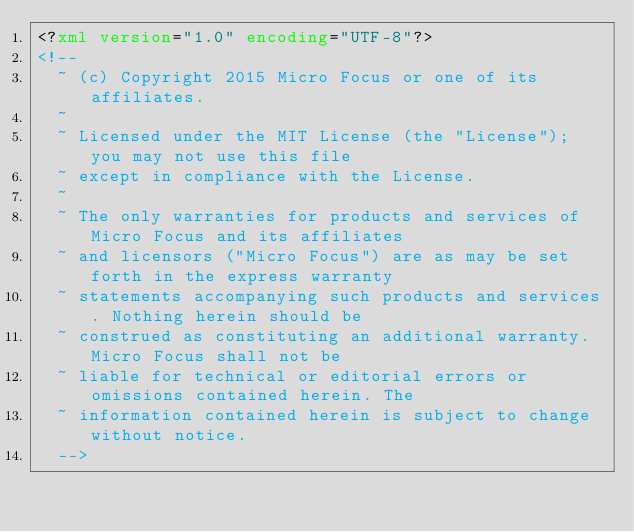<code> <loc_0><loc_0><loc_500><loc_500><_XML_><?xml version="1.0" encoding="UTF-8"?>
<!--
  ~ (c) Copyright 2015 Micro Focus or one of its affiliates.
  ~
  ~ Licensed under the MIT License (the "License"); you may not use this file
  ~ except in compliance with the License.
  ~
  ~ The only warranties for products and services of Micro Focus and its affiliates
  ~ and licensors ("Micro Focus") are as may be set forth in the express warranty
  ~ statements accompanying such products and services. Nothing herein should be
  ~ construed as constituting an additional warranty. Micro Focus shall not be
  ~ liable for technical or editorial errors or omissions contained herein. The
  ~ information contained herein is subject to change without notice.
  -->
</code> 